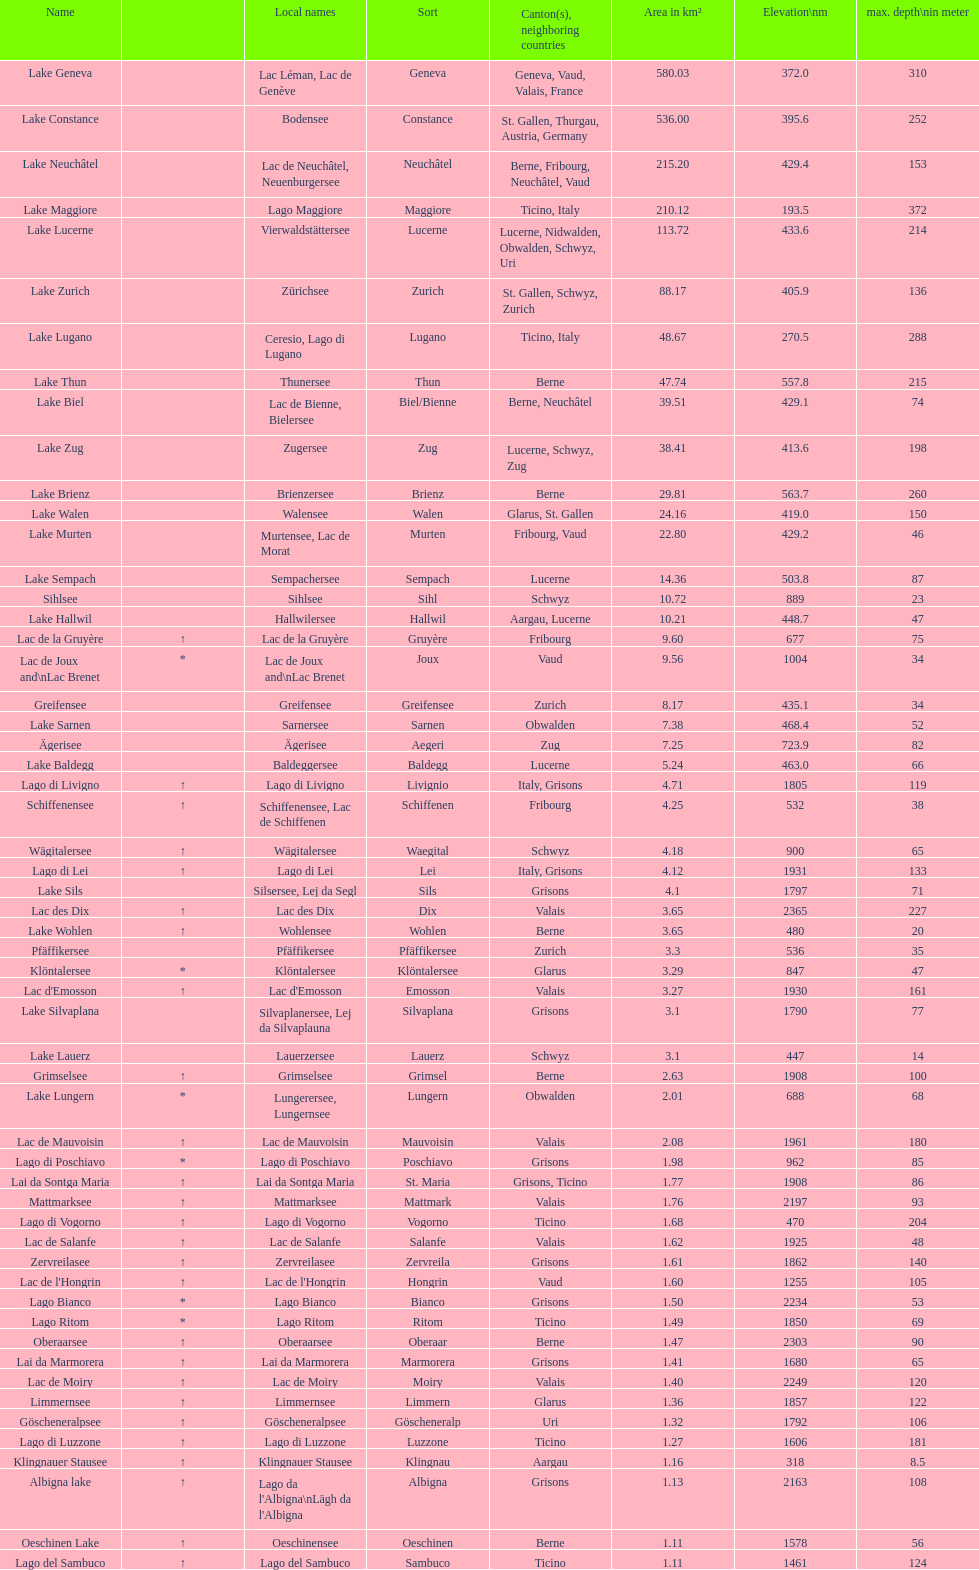What is the complete area in km² of lake sils? 4.1. 